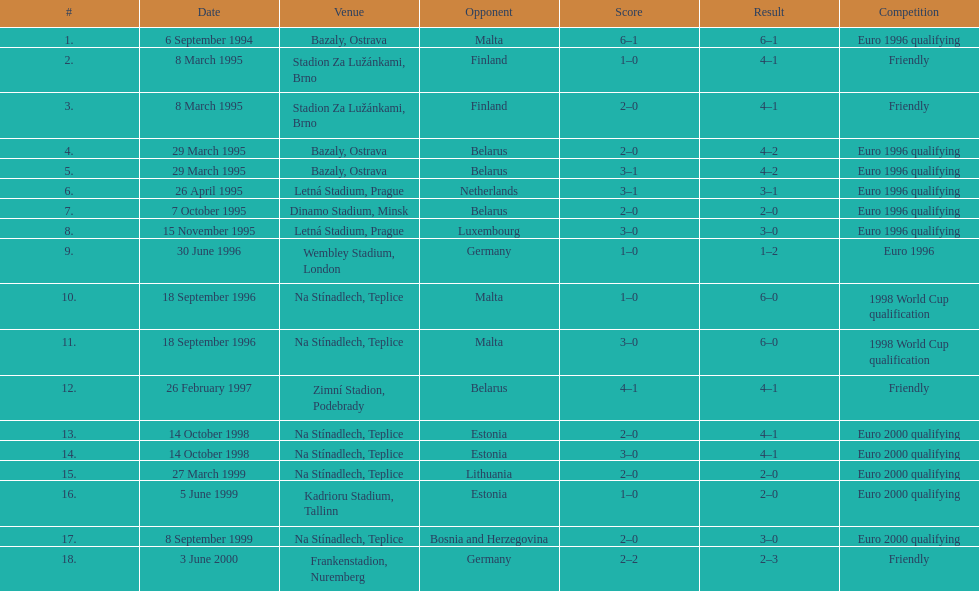Bazaly, ostrava was used on 6 september 1004, but what venue was used on 18 september 1996? Na Stínadlech, Teplice. 